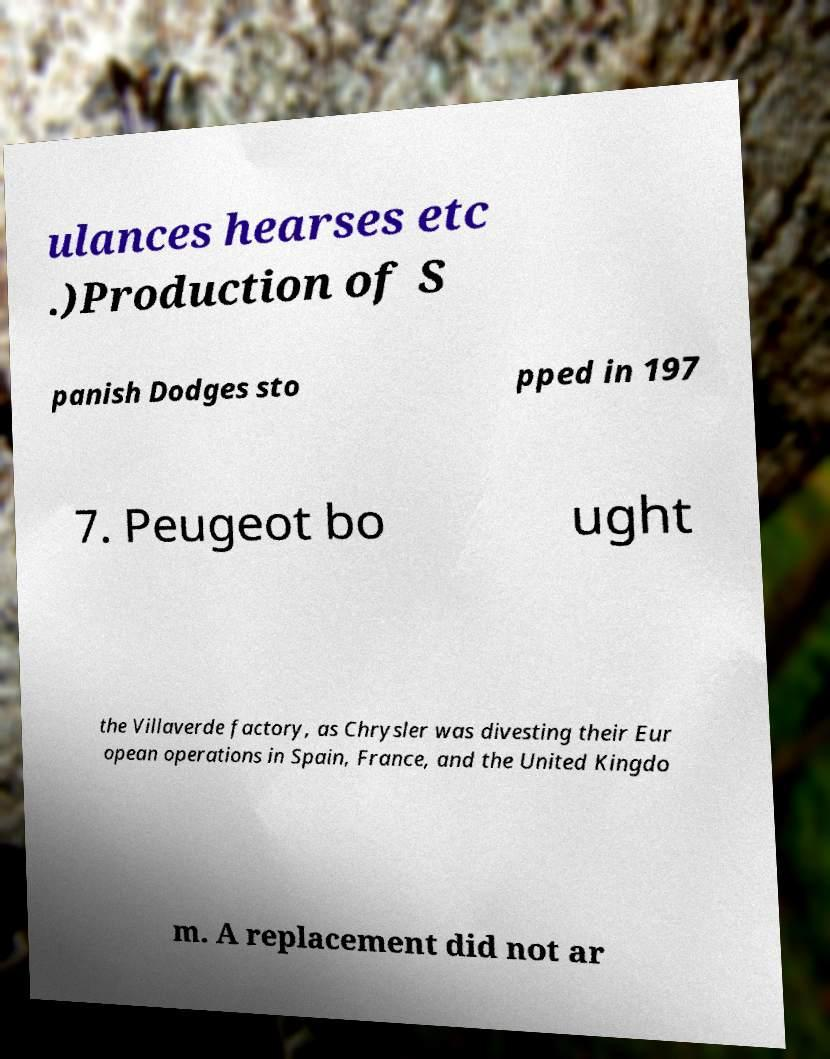I need the written content from this picture converted into text. Can you do that? ulances hearses etc .)Production of S panish Dodges sto pped in 197 7. Peugeot bo ught the Villaverde factory, as Chrysler was divesting their Eur opean operations in Spain, France, and the United Kingdo m. A replacement did not ar 